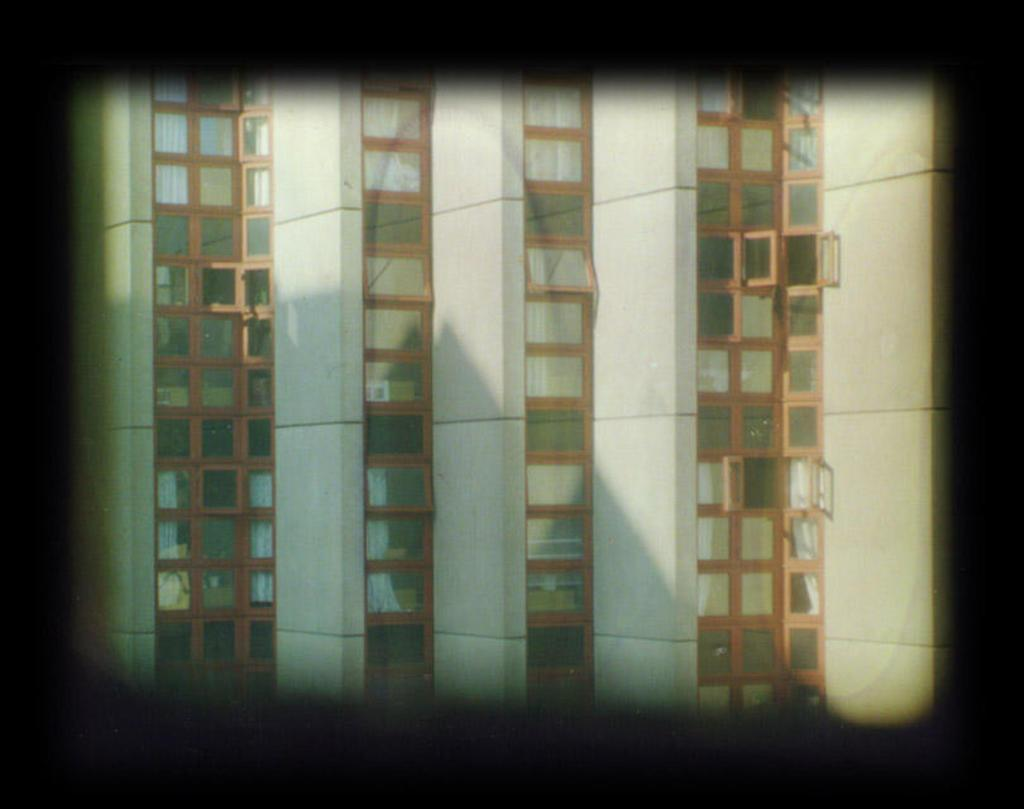What can be observed about the image's appearance? The image is edited. What type of structures are present in the image? There are buildings in the image. What specific feature can be seen in the middle of the image? There are glass windows in the middle of the image. What type of plantation can be seen in the image? There is no plantation present in the image; it features buildings and glass windows. What kind of tools might a carpenter use in the image? There is no carpenter or carpentry work depicted in the image, so it is not possible to determine what tools might be used. 